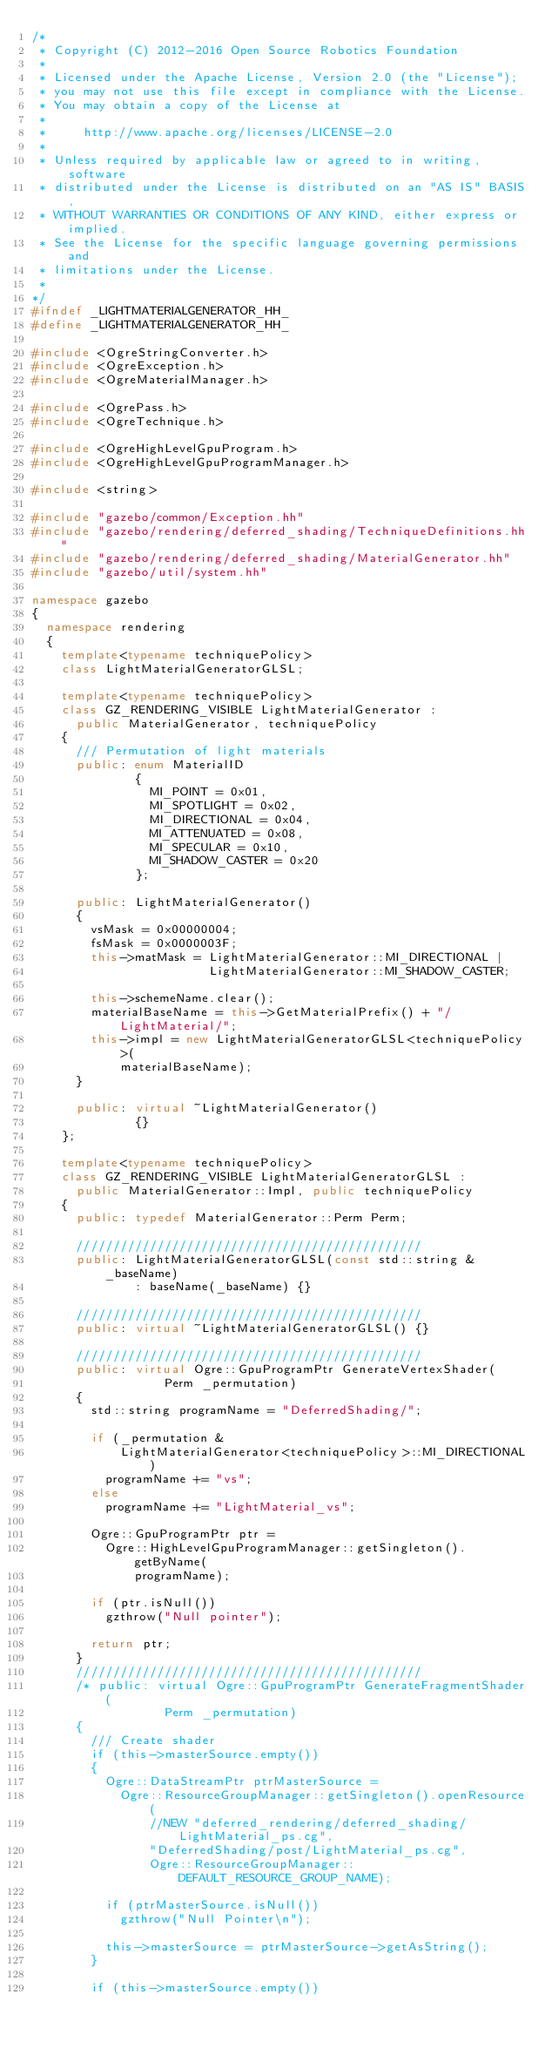<code> <loc_0><loc_0><loc_500><loc_500><_C++_>/*
 * Copyright (C) 2012-2016 Open Source Robotics Foundation
 *
 * Licensed under the Apache License, Version 2.0 (the "License");
 * you may not use this file except in compliance with the License.
 * You may obtain a copy of the License at
 *
 *     http://www.apache.org/licenses/LICENSE-2.0
 *
 * Unless required by applicable law or agreed to in writing, software
 * distributed under the License is distributed on an "AS IS" BASIS,
 * WITHOUT WARRANTIES OR CONDITIONS OF ANY KIND, either express or implied.
 * See the License for the specific language governing permissions and
 * limitations under the License.
 *
*/
#ifndef _LIGHTMATERIALGENERATOR_HH_
#define _LIGHTMATERIALGENERATOR_HH_

#include <OgreStringConverter.h>
#include <OgreException.h>
#include <OgreMaterialManager.h>

#include <OgrePass.h>
#include <OgreTechnique.h>

#include <OgreHighLevelGpuProgram.h>
#include <OgreHighLevelGpuProgramManager.h>

#include <string>

#include "gazebo/common/Exception.hh"
#include "gazebo/rendering/deferred_shading/TechniqueDefinitions.hh"
#include "gazebo/rendering/deferred_shading/MaterialGenerator.hh"
#include "gazebo/util/system.hh"

namespace gazebo
{
  namespace rendering
  {
    template<typename techniquePolicy>
    class LightMaterialGeneratorGLSL;

    template<typename techniquePolicy>
    class GZ_RENDERING_VISIBLE LightMaterialGenerator :
      public MaterialGenerator, techniquePolicy
    {
      /// Permutation of light materials
      public: enum MaterialID
              {
                MI_POINT = 0x01,
                MI_SPOTLIGHT = 0x02,
                MI_DIRECTIONAL = 0x04,
                MI_ATTENUATED = 0x08,
                MI_SPECULAR = 0x10,
                MI_SHADOW_CASTER = 0x20
              };

      public: LightMaterialGenerator()
      {
        vsMask = 0x00000004;
        fsMask = 0x0000003F;
        this->matMask = LightMaterialGenerator::MI_DIRECTIONAL |
                        LightMaterialGenerator::MI_SHADOW_CASTER;

        this->schemeName.clear();
        materialBaseName = this->GetMaterialPrefix() + "/LightMaterial/";
        this->impl = new LightMaterialGeneratorGLSL<techniquePolicy>(
            materialBaseName);
      }

      public: virtual ~LightMaterialGenerator()
              {}
    };

    template<typename techniquePolicy>
    class GZ_RENDERING_VISIBLE LightMaterialGeneratorGLSL :
      public MaterialGenerator::Impl, public techniquePolicy
    {
      public: typedef MaterialGenerator::Perm Perm;

      ///////////////////////////////////////////////
      public: LightMaterialGeneratorGLSL(const std::string &_baseName)
              : baseName(_baseName) {}

      ///////////////////////////////////////////////
      public: virtual ~LightMaterialGeneratorGLSL() {}

      ///////////////////////////////////////////////
      public: virtual Ogre::GpuProgramPtr GenerateVertexShader(
                  Perm _permutation)
      {
        std::string programName = "DeferredShading/";

        if (_permutation &
            LightMaterialGenerator<techniquePolicy>::MI_DIRECTIONAL)
          programName += "vs";
        else
          programName += "LightMaterial_vs";

        Ogre::GpuProgramPtr ptr =
          Ogre::HighLevelGpuProgramManager::getSingleton().getByName(
              programName);

        if (ptr.isNull())
          gzthrow("Null pointer");

        return ptr;
      }
      ///////////////////////////////////////////////
      /* public: virtual Ogre::GpuProgramPtr GenerateFragmentShader(
                  Perm _permutation)
      {
        /// Create shader
        if (this->masterSource.empty())
        {
          Ogre::DataStreamPtr ptrMasterSource =
            Ogre::ResourceGroupManager::getSingleton().openResource(
                //NEW "deferred_rendering/deferred_shading/LightMaterial_ps.cg",
                "DeferredShading/post/LightMaterial_ps.cg",
                Ogre::ResourceGroupManager::DEFAULT_RESOURCE_GROUP_NAME);

          if (ptrMasterSource.isNull())
            gzthrow("Null Pointer\n");

          this->masterSource = ptrMasterSource->getAsString();
        }

        if (this->masterSource.empty())</code> 